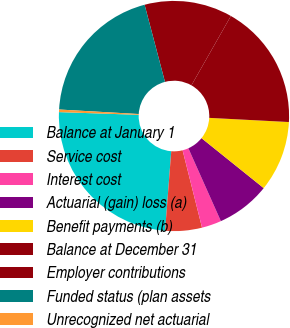<chart> <loc_0><loc_0><loc_500><loc_500><pie_chart><fcel>Balance at January 1<fcel>Service cost<fcel>Interest cost<fcel>Actuarial (gain) loss (a)<fcel>Benefit payments (b)<fcel>Balance at December 31<fcel>Employer contributions<fcel>Funded status (plan assets<fcel>Unrecognized net actuarial<nl><fcel>24.31%<fcel>5.15%<fcel>2.76%<fcel>7.55%<fcel>9.94%<fcel>17.6%<fcel>12.34%<fcel>19.99%<fcel>0.36%<nl></chart> 